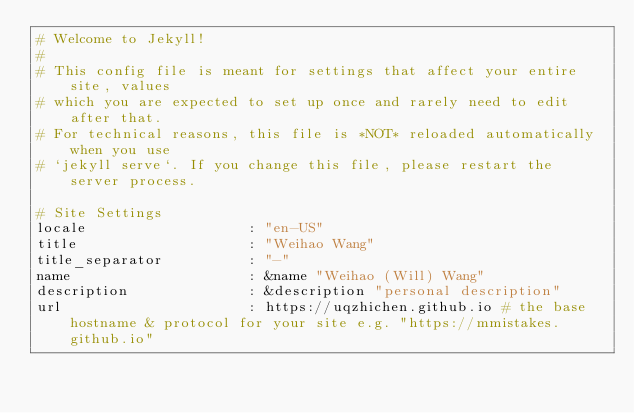<code> <loc_0><loc_0><loc_500><loc_500><_YAML_># Welcome to Jekyll!
#
# This config file is meant for settings that affect your entire site, values
# which you are expected to set up once and rarely need to edit after that.
# For technical reasons, this file is *NOT* reloaded automatically when you use
# `jekyll serve`. If you change this file, please restart the server process.

# Site Settings
locale                   : "en-US"
title                    : "Weihao Wang"
title_separator          : "-"
name                     : &name "Weihao (Will) Wang"
description              : &description "personal description"
url                      : https://uqzhichen.github.io # the base hostname & protocol for your site e.g. "https://mmistakes.github.io"</code> 